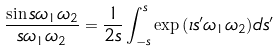Convert formula to latex. <formula><loc_0><loc_0><loc_500><loc_500>\frac { \sin { s \omega _ { 1 } \omega _ { 2 } } } { s \omega _ { 1 } \omega _ { 2 } } = \frac { 1 } { 2 s } \int _ { - s } ^ { s } \exp { \left ( \imath s ^ { \prime } \omega _ { 1 } \omega _ { 2 } \right ) } d s ^ { \prime }</formula> 